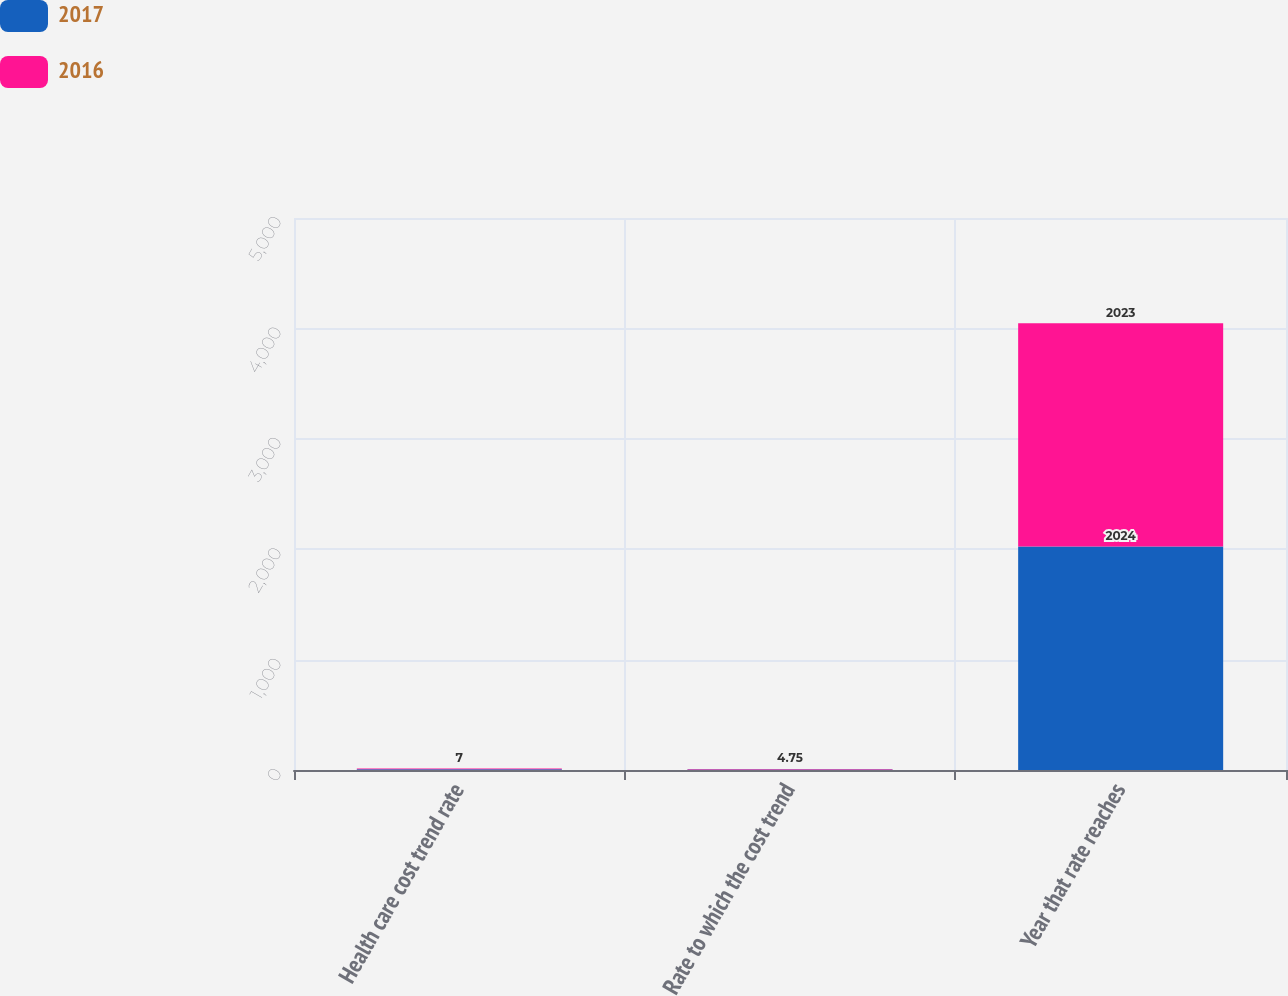<chart> <loc_0><loc_0><loc_500><loc_500><stacked_bar_chart><ecel><fcel>Health care cost trend rate<fcel>Rate to which the cost trend<fcel>Year that rate reaches<nl><fcel>2017<fcel>7<fcel>4.75<fcel>2024<nl><fcel>2016<fcel>7<fcel>4.75<fcel>2023<nl></chart> 